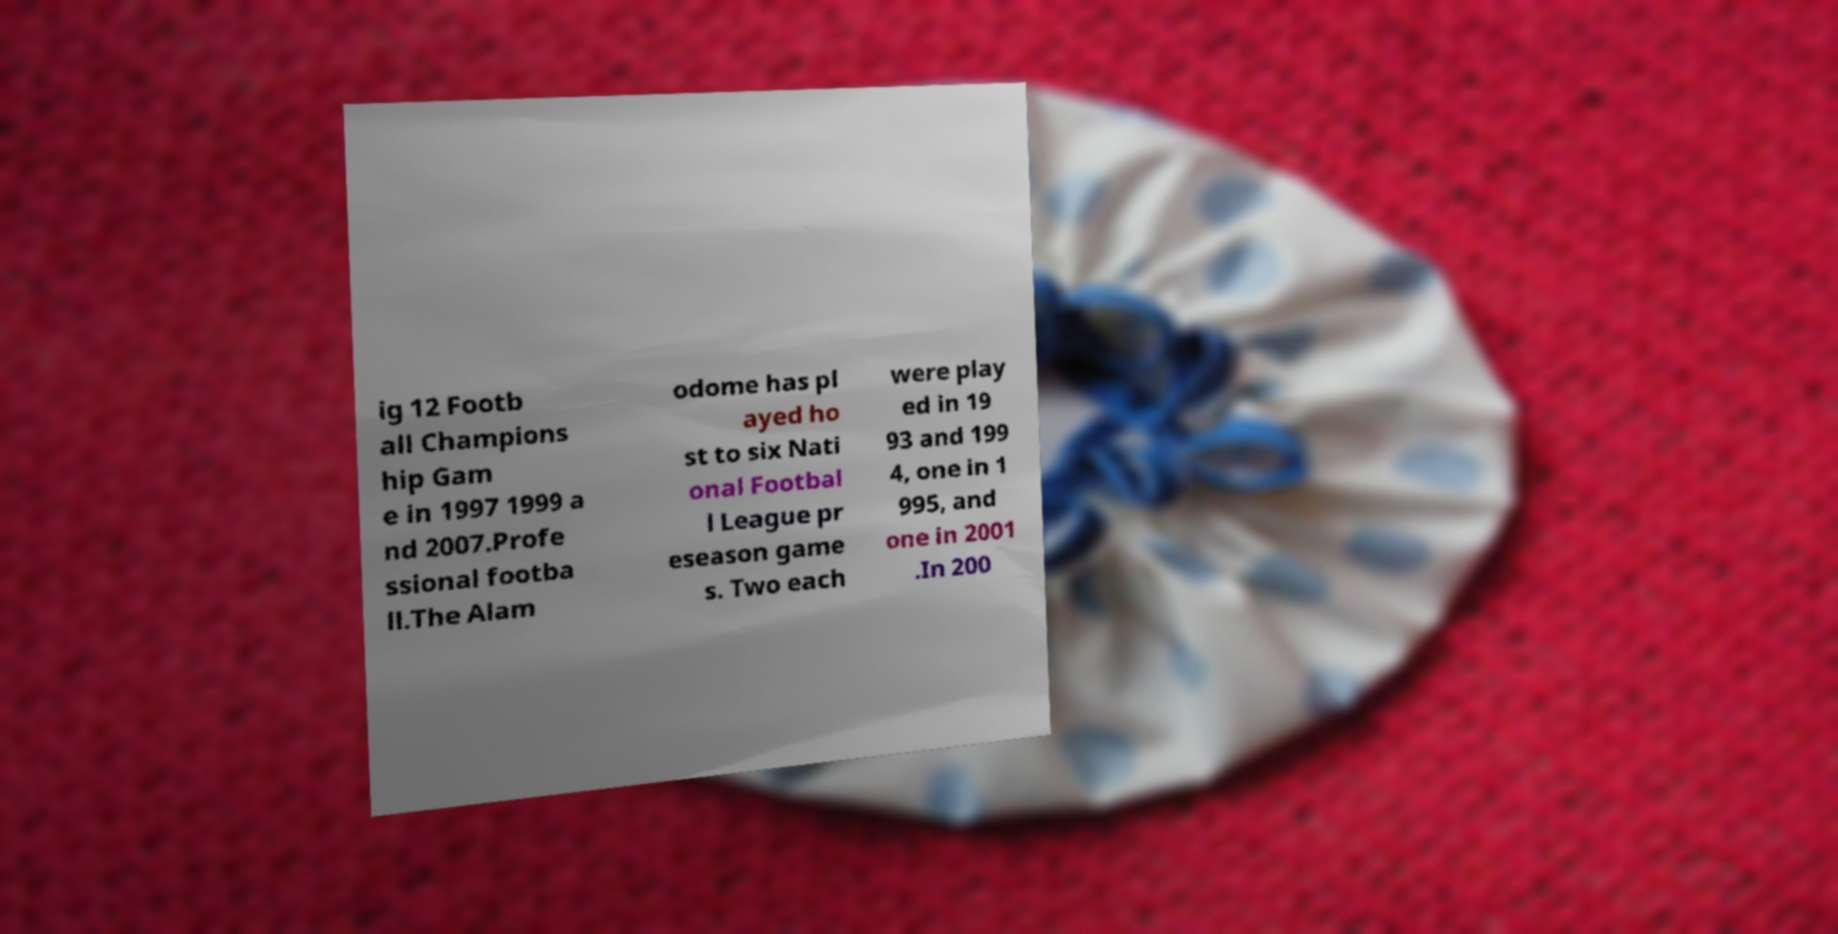I need the written content from this picture converted into text. Can you do that? ig 12 Footb all Champions hip Gam e in 1997 1999 a nd 2007.Profe ssional footba ll.The Alam odome has pl ayed ho st to six Nati onal Footbal l League pr eseason game s. Two each were play ed in 19 93 and 199 4, one in 1 995, and one in 2001 .In 200 